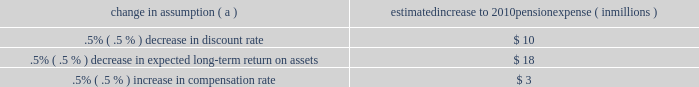Investment policy , which is described more fully in note 15 employee benefit plans in the notes to consolidated financial statements in item 8 of this report .
We calculate the expense associated with the pension plan and the assumptions and methods that we use include a policy of reflecting trust assets at their fair market value .
On an annual basis , we review the actuarial assumptions related to the pension plan , including the discount rate , the rate of compensation increase and the expected return on plan assets .
The discount rate and compensation increase assumptions do not significantly affect pension expense .
However , the expected long-term return on assets assumption does significantly affect pension expense .
Our expected long- term return on plan assets for determining net periodic pension expense has been 8.25% ( 8.25 % ) for the past three years .
The expected return on plan assets is a long-term assumption established by considering historical and anticipated returns of the asset classes invested in by the pension plan and the allocation strategy currently in place among those classes .
While this analysis gives appropriate consideration to recent asset performance and historical returns , the assumption represents a long-term prospective return .
We review this assumption at each measurement date and adjust it if warranted .
For purposes of setting and reviewing this assumption , 201clong- term 201d refers to the period over which the plan 2019s projected benefit obligation will be disbursed .
While year-to-year annual returns can vary significantly ( rates of return for the reporting years of 2009 , 2008 , and 2007 were +20.61% ( +20.61 % ) , -32.91% ( -32.91 % ) , and +7.57% ( +7.57 % ) , respectively ) , the assumption represents our estimate of long-term average prospective returns .
Our selection process references certain historical data and the current environment , but primarily utilizes qualitative judgment regarding future return expectations .
Recent annual returns may differ but , recognizing the volatility and unpredictability of investment returns , we generally do not change the assumption unless we modify our investment strategy or identify events that would alter our expectations of future returns .
To evaluate the continued reasonableness of our assumption , we examine a variety of viewpoints and data .
Various studies have shown that portfolios comprised primarily of us equity securities have returned approximately 10% ( 10 % ) over long periods of time , while us debt securities have returned approximately 6% ( 6 % ) annually over long periods .
Application of these historical returns to the plan 2019s allocation of equities and bonds produces a result between 8% ( 8 % ) and 8.5% ( 8.5 % ) and is one point of reference , among many other factors , that is taken into consideration .
We also examine the plan 2019s actual historical returns over various periods .
Recent experience is considered in our evaluation with appropriate consideration that , especially for short time periods , recent returns are not reliable indicators of future returns , and in many cases low returns in recent time periods are followed by higher returns in future periods ( and vice versa ) .
Acknowledging the potentially wide range for this assumption , we also annually examine the assumption used by other companies with similar pension investment strategies , so that we can ascertain whether our determinations markedly differ from other observers .
In all cases , however , this data simply informs our process , which places the greatest emphasis on our qualitative judgment of future investment returns , given the conditions existing at each annual measurement date .
The expected long-term return on plan assets for determining net periodic pension cost for 2009 was 8.25% ( 8.25 % ) , unchanged from 2008 .
During 2010 , we intend to decrease the midpoint of the plan 2019s target allocation range for equities by approximately five percentage points .
As a result of this change and taking into account all other factors described above , pnc will change the expected long-term return on plan assets to 8.00% ( 8.00 % ) for determining net periodic pension cost for 2010 .
Under current accounting rules , the difference between expected long-term returns and actual returns is accumulated and amortized to pension expense over future periods .
Each one percentage point difference in actual return compared with our expected return causes expense in subsequent years to change by up to $ 8 million as the impact is amortized into results of operations .
The table below reflects the estimated effects on pension expense of certain changes in annual assumptions , using 2010 estimated expense as a baseline .
Change in assumption ( a ) estimated increase to 2010 pension expense ( in millions ) .
( a ) the impact is the effect of changing the specified assumption while holding all other assumptions constant .
We currently estimate a pretax pension expense of $ 41 million in 2010 compared with pretax expense of $ 117 million in 2009 .
This year-over-year reduction was primarily due to the amortization impact of the favorable 2009 investment returns as compared with the expected long-term return assumption .
Our pension plan contribution requirements are not particularly sensitive to actuarial assumptions .
Investment performance has the most impact on contribution requirements and will drive the amount of permitted contributions in future years .
Also , current law , including the provisions of the pension protection act of 2006 , sets limits as to both minimum and maximum contributions to the plan .
We expect that the minimum required contributions under the law will be zero for 2010 .
We maintain other defined benefit plans that have a less significant effect on financial results , including various .
The pretax pension expenses that reduced primarily due to the amortization impact of the favorable 2009 investment returns as compared with the expected long-term return assumption resulted in how much of a decreased expense from 2009 to 2010 , in millions? 
Computations: (117 - 41)
Answer: 76.0. 